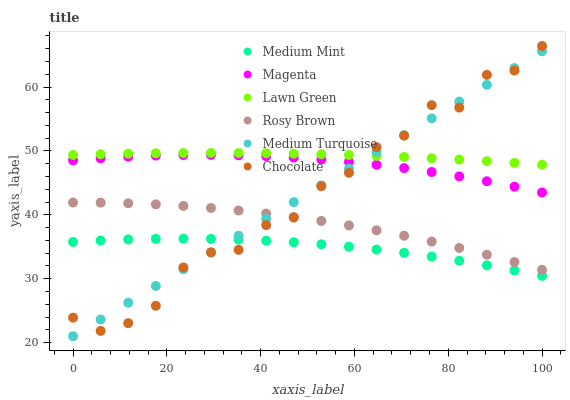Does Medium Mint have the minimum area under the curve?
Answer yes or no. Yes. Does Lawn Green have the maximum area under the curve?
Answer yes or no. Yes. Does Rosy Brown have the minimum area under the curve?
Answer yes or no. No. Does Rosy Brown have the maximum area under the curve?
Answer yes or no. No. Is Medium Turquoise the smoothest?
Answer yes or no. Yes. Is Chocolate the roughest?
Answer yes or no. Yes. Is Lawn Green the smoothest?
Answer yes or no. No. Is Lawn Green the roughest?
Answer yes or no. No. Does Medium Turquoise have the lowest value?
Answer yes or no. Yes. Does Rosy Brown have the lowest value?
Answer yes or no. No. Does Chocolate have the highest value?
Answer yes or no. Yes. Does Lawn Green have the highest value?
Answer yes or no. No. Is Rosy Brown less than Lawn Green?
Answer yes or no. Yes. Is Lawn Green greater than Magenta?
Answer yes or no. Yes. Does Medium Mint intersect Medium Turquoise?
Answer yes or no. Yes. Is Medium Mint less than Medium Turquoise?
Answer yes or no. No. Is Medium Mint greater than Medium Turquoise?
Answer yes or no. No. Does Rosy Brown intersect Lawn Green?
Answer yes or no. No. 